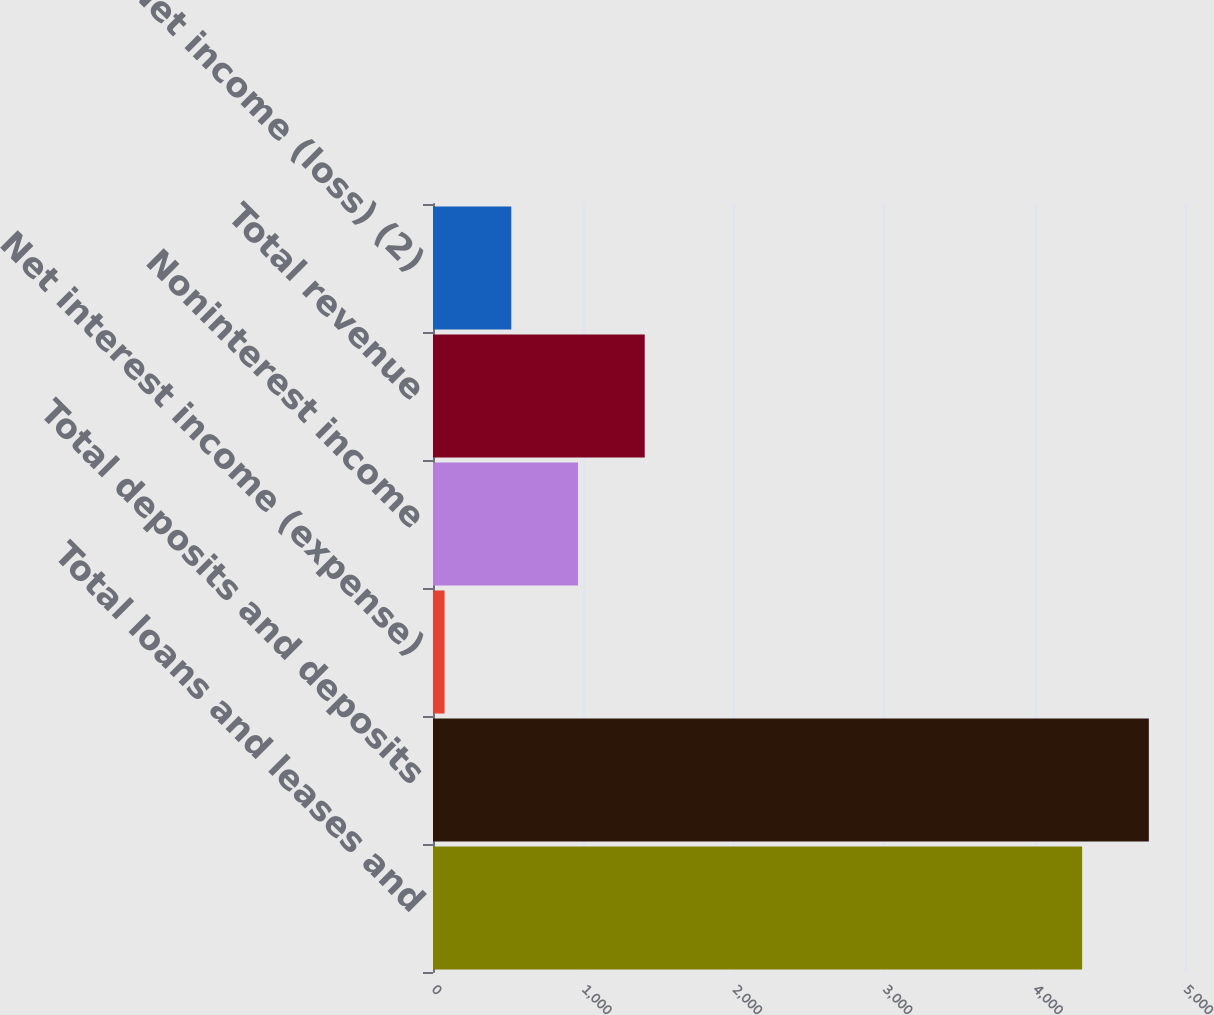<chart> <loc_0><loc_0><loc_500><loc_500><bar_chart><fcel>Total loans and leases and<fcel>Total deposits and deposits<fcel>Net interest income (expense)<fcel>Noninterest income<fcel>Total revenue<fcel>Net income (loss) (2)<nl><fcel>4316<fcel>4759.6<fcel>77<fcel>964.2<fcel>1407.8<fcel>520.6<nl></chart> 